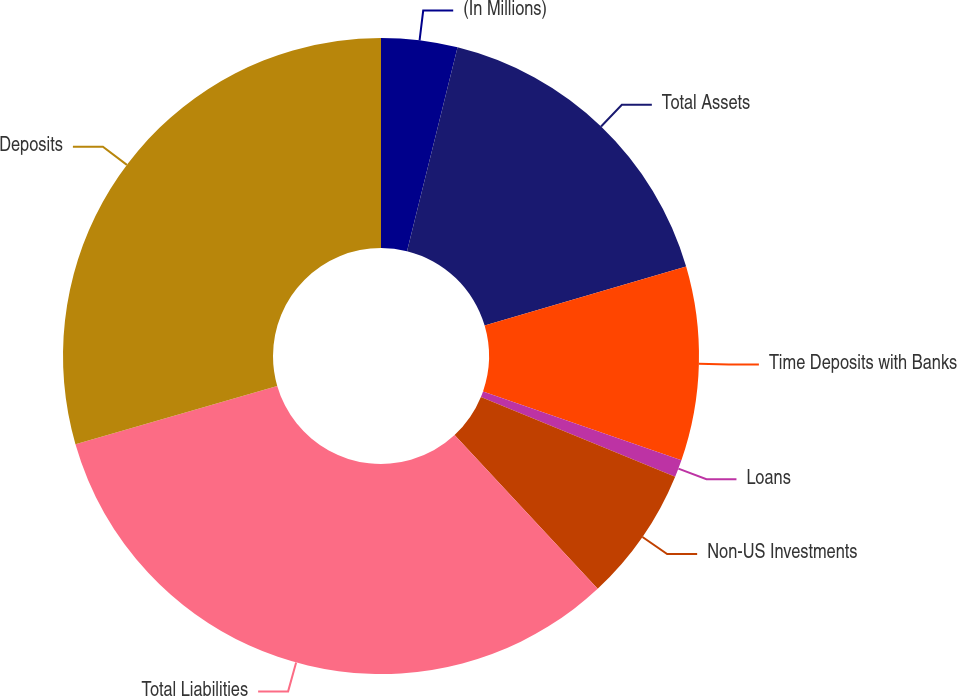<chart> <loc_0><loc_0><loc_500><loc_500><pie_chart><fcel>(In Millions)<fcel>Total Assets<fcel>Time Deposits with Banks<fcel>Loans<fcel>Non-US Investments<fcel>Total Liabilities<fcel>Deposits<nl><fcel>3.87%<fcel>16.59%<fcel>9.86%<fcel>0.88%<fcel>6.87%<fcel>32.46%<fcel>29.47%<nl></chart> 